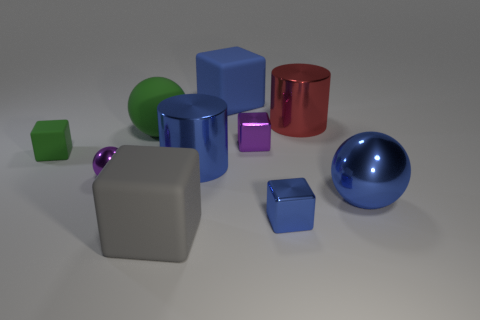There is a tiny shiny thing that is to the left of the big matte thing in front of the tiny green rubber cube; is there a small metal sphere to the left of it?
Your answer should be compact. No. What is the shape of the green matte thing that is the same size as the purple sphere?
Provide a short and direct response. Cube. Are there any other big spheres of the same color as the big rubber ball?
Keep it short and to the point. No. Do the big green matte object and the gray thing have the same shape?
Your response must be concise. No. What number of tiny things are either yellow metal objects or purple spheres?
Make the answer very short. 1. What is the color of the sphere that is made of the same material as the big gray block?
Your response must be concise. Green. How many small green cubes have the same material as the large blue block?
Give a very brief answer. 1. Do the cylinder that is right of the blue rubber thing and the matte thing that is behind the green ball have the same size?
Keep it short and to the point. Yes. What material is the large sphere to the right of the blue object behind the red cylinder made of?
Your answer should be compact. Metal. Is the number of large matte blocks that are behind the blue cylinder less than the number of shiny things that are behind the small purple metallic block?
Keep it short and to the point. No. 